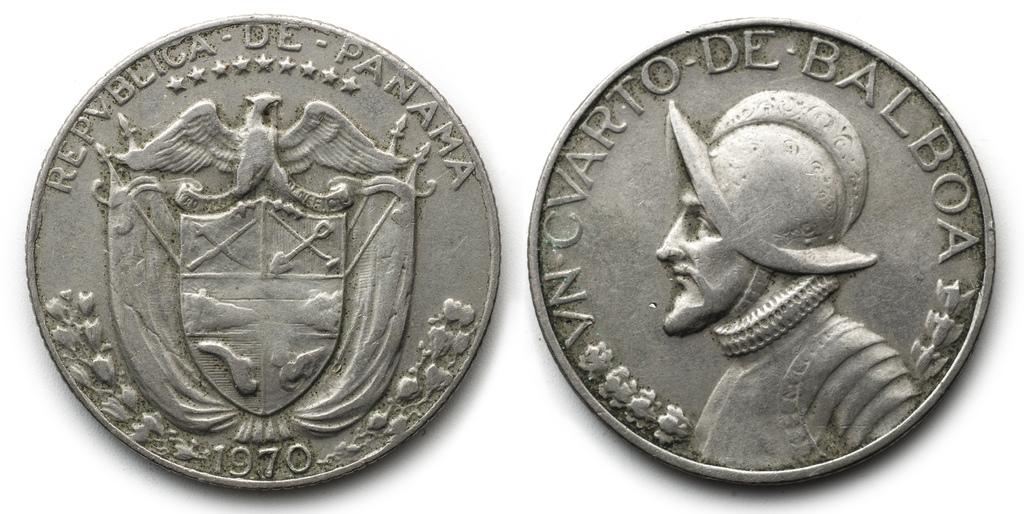What country is this post from?
Provide a short and direct response. Panama. 